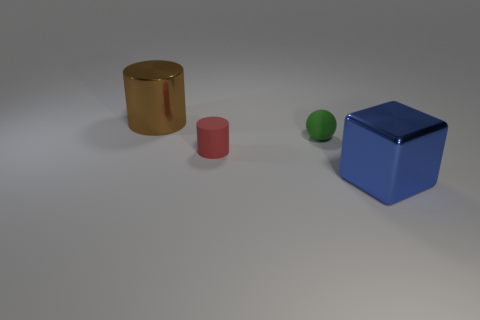The green rubber object that is the same size as the red matte thing is what shape? sphere 